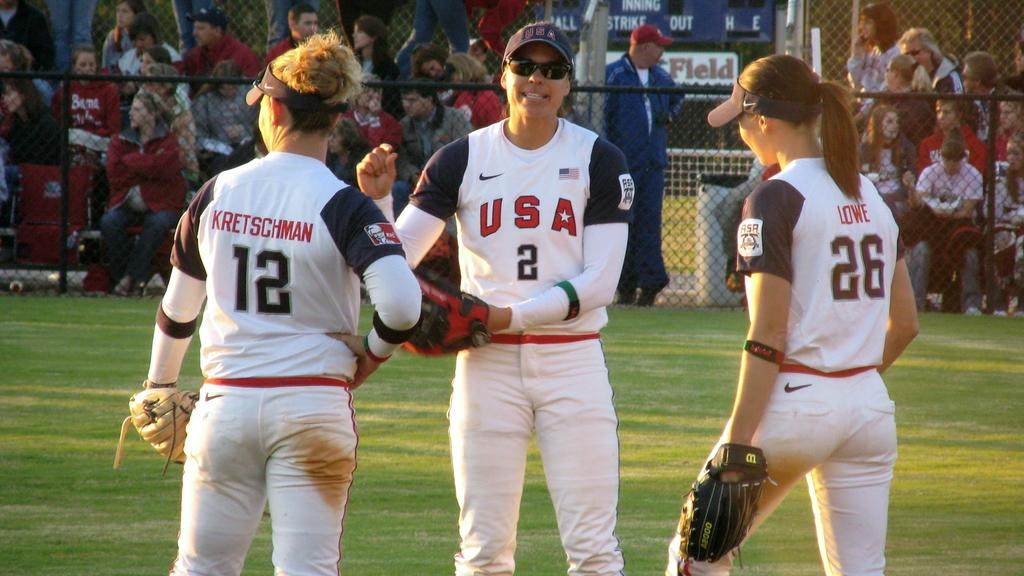Provide a one-sentence caption for the provided image. a few girls that are wearing jerseys that say USA. 